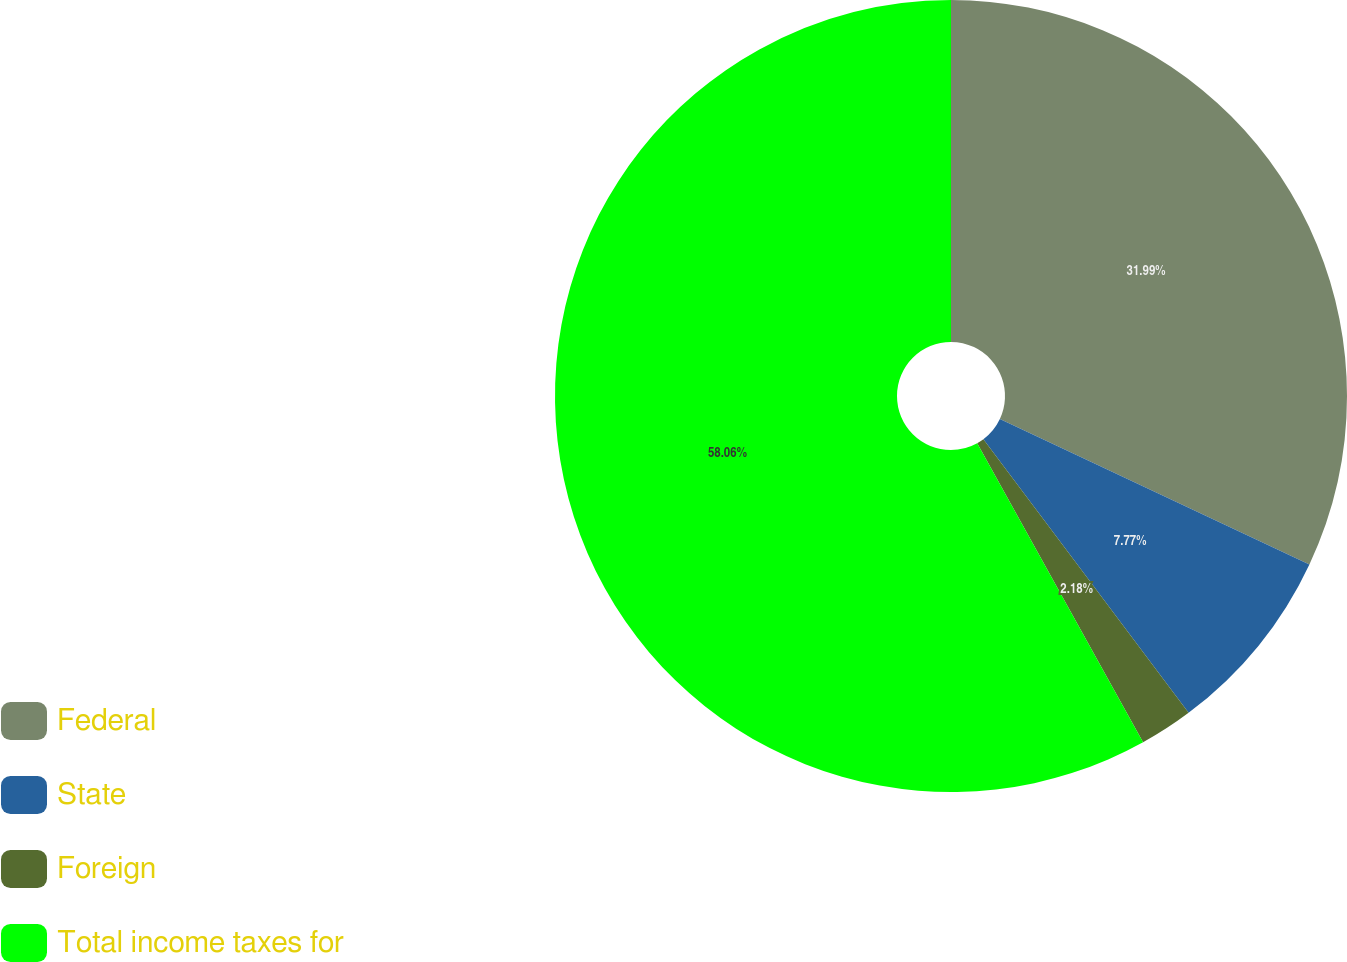Convert chart. <chart><loc_0><loc_0><loc_500><loc_500><pie_chart><fcel>Federal<fcel>State<fcel>Foreign<fcel>Total income taxes for<nl><fcel>31.99%<fcel>7.77%<fcel>2.18%<fcel>58.06%<nl></chart> 